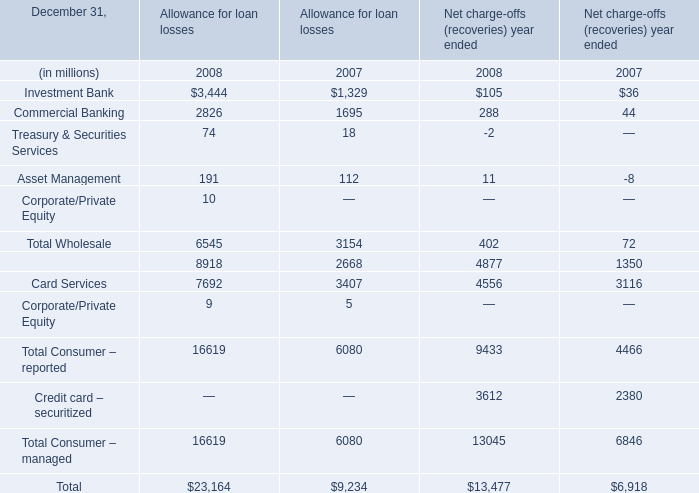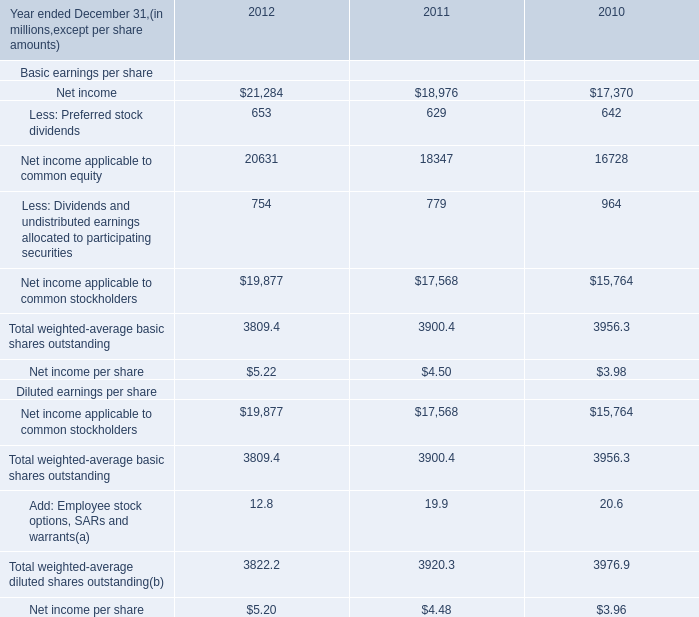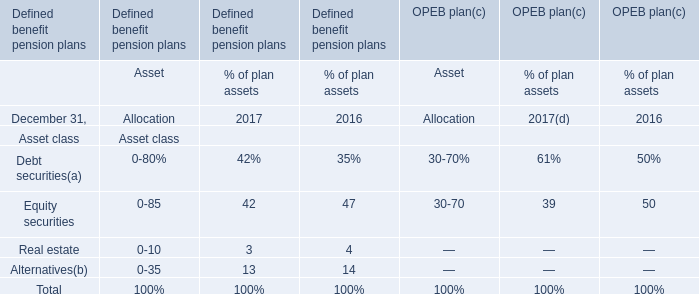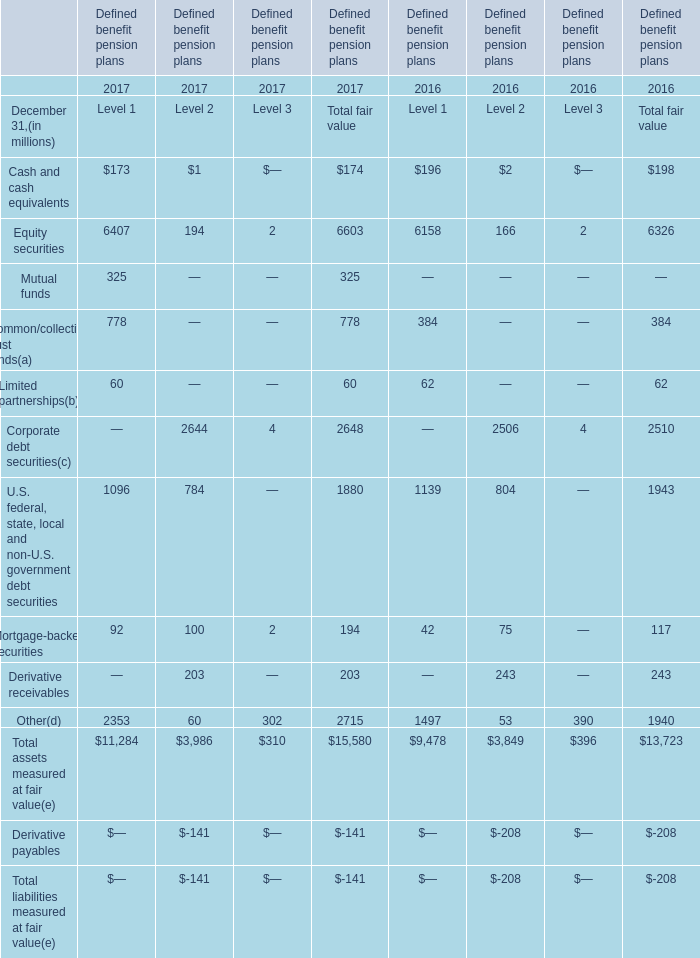Which year is Retail Financial Services of Net charge-offs (recoveries) year ended the highest? 
Answer: 2008. 